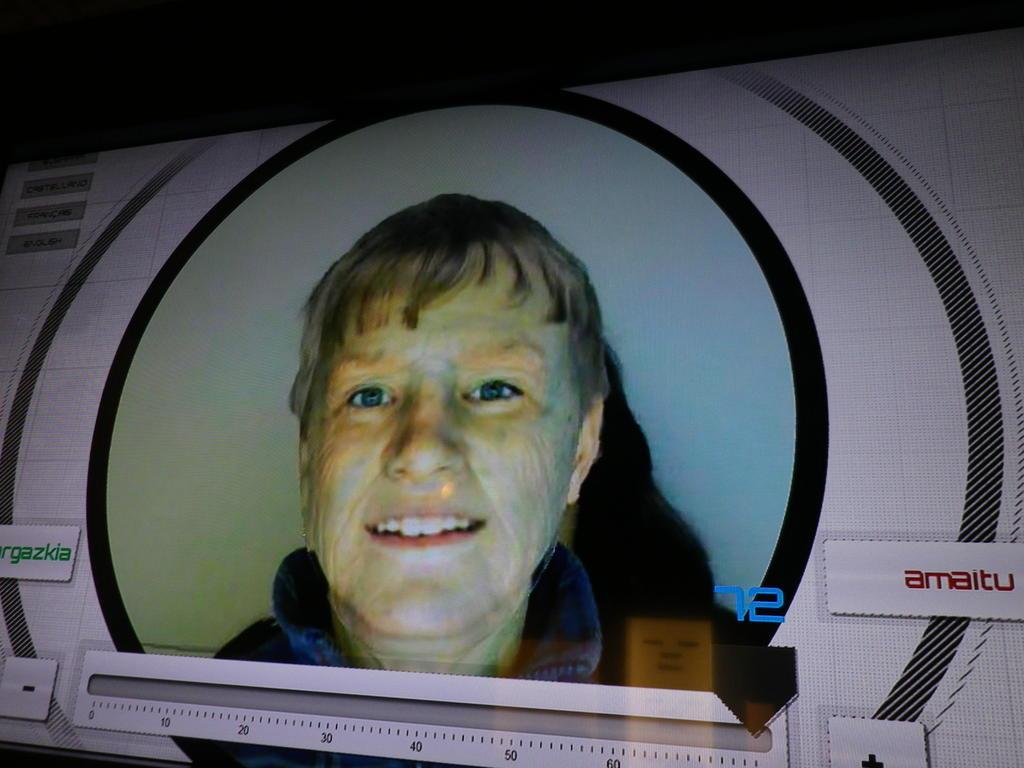What is the main object in the image? There is a screen in the image. What can be seen on the screen? A person's image is displayed on the screen. How would you describe the overall color of the image's background? The background of the image is dark in color. Can you tell me how many snakes are slithering on the screen in the image? There are no snakes present in the image; the screen displays a person's image. What type of ear is visible on the person's image on the screen? There is no ear visible on the person's image on the screen, as the image only shows the person's face. 